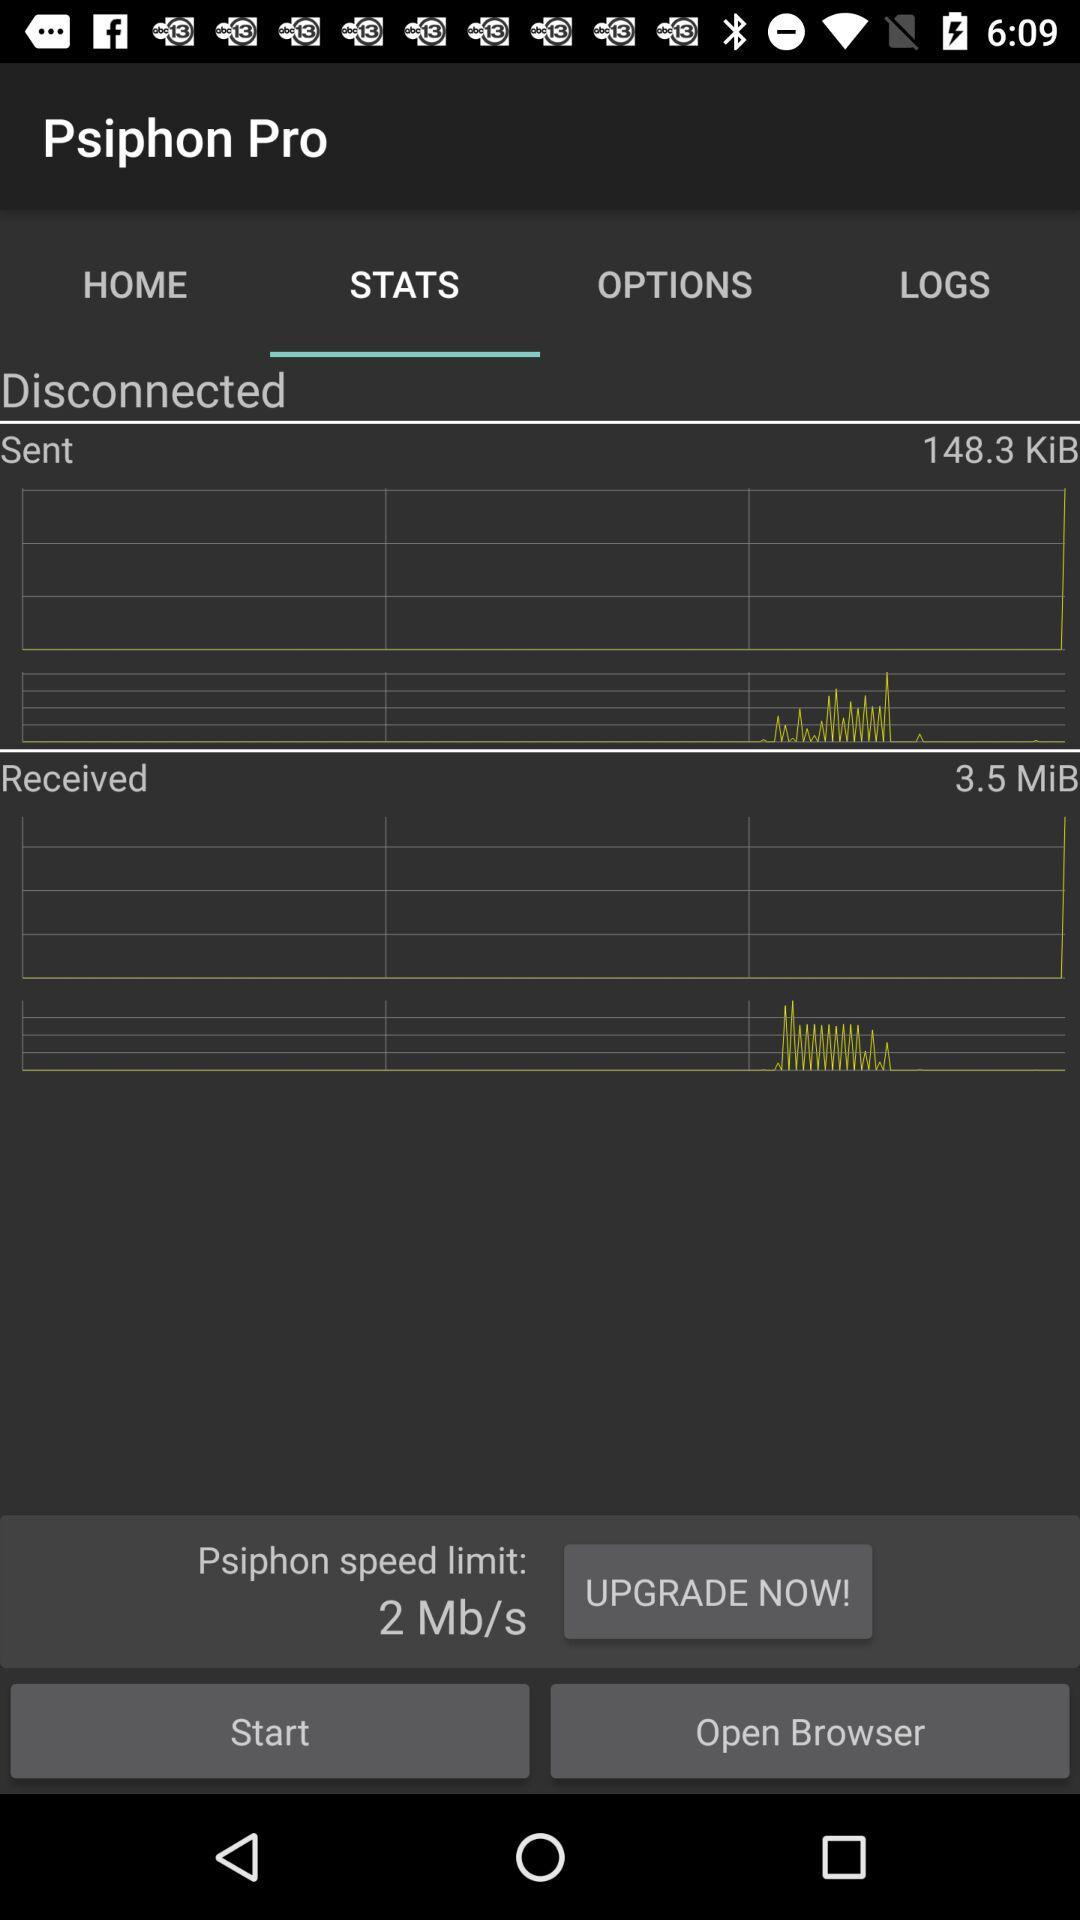How much data has been sent in KiB? The sent data is 148.3 KiB. 